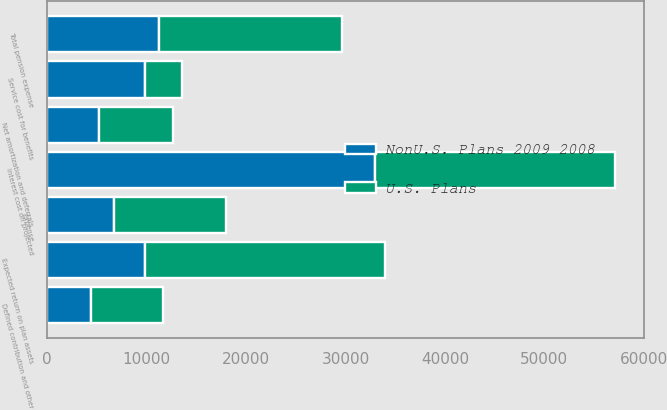Convert chart. <chart><loc_0><loc_0><loc_500><loc_500><stacked_bar_chart><ecel><fcel>Service cost for benefits<fcel>Interest cost on projected<fcel>Expected return on plan assets<fcel>Net amortization and deferrals<fcel>Expense<fcel>Defined contribution and other<fcel>Total pension expense<nl><fcel>U.S. Plans<fcel>3781<fcel>24191<fcel>24146<fcel>7441<fcel>11267<fcel>7169<fcel>18436<nl><fcel>NonU.S. Plans 2009 2008<fcel>9804<fcel>32954<fcel>9804<fcel>5214<fcel>6763<fcel>4459<fcel>11222<nl></chart> 